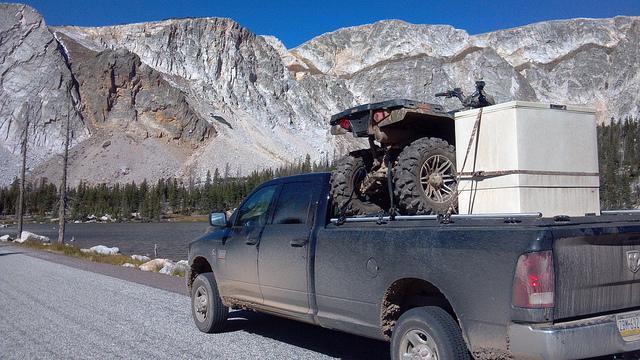How many trucks can you see?
Give a very brief answer. 1. How many people are wearing protective face masks?
Give a very brief answer. 0. 